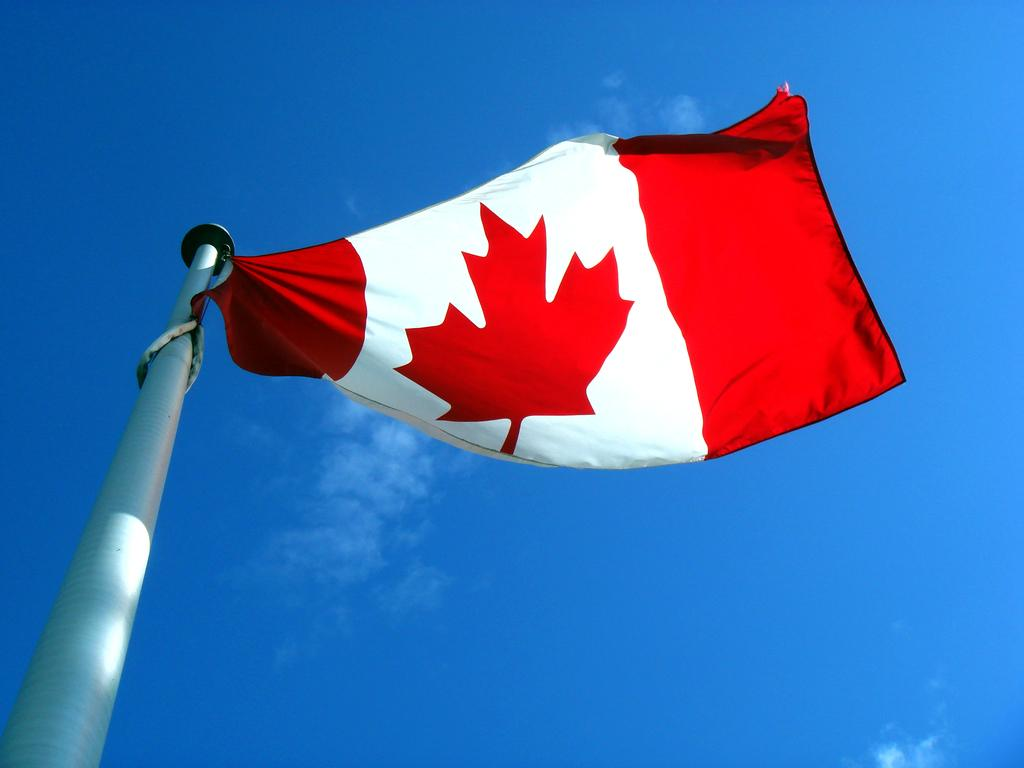What is located on the left side of the image? There is a flag on the left side of the image. What can be seen in the sky in the background of the image? There are clouds visible in the sky in the background of the image. What is the price of the ladybug in the image? There is no ladybug present in the image, so it is not possible to determine its price. 